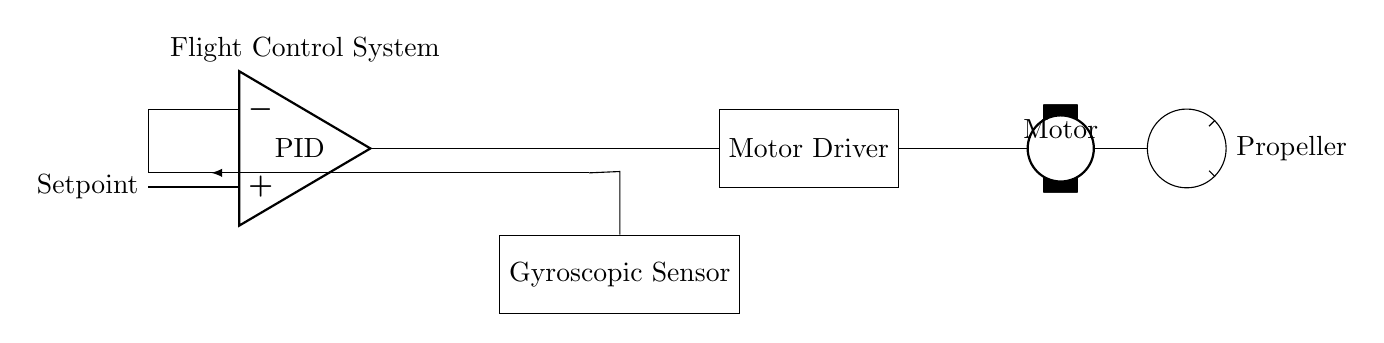What is the main function of the PID controller? The PID controller's main function is to maintain the desired flight path or attitude by adjusting the control signals to the motor based on the error from the setpoint.
Answer: To control flight What type of sensor is used in this system? The circuit diagram shows a gyroscopic sensor, which is used to detect the orientation and angular velocity of the drone.
Answer: Gyroscopic sensor How many main components are present in the flight control system? There are four main components in the system: PID controller, gyroscopic sensor, motor driver, and motor with propeller.
Answer: Four What signifies the feedback loop in the circuit? The feedback loop is indicated by the connection from the gyroscopic sensor back to the PID controller, allowing for real-time adjustments based on the drone's orientation.
Answer: Feedback connection What does the motor driver do in this circuit? The motor driver receives signals from the PID controller and adjusts the power supplied to the motor, controlling its speed and direction.
Answer: Controls motor Which component processes the setpoint signal? The PID controller processes the setpoint signal to maintain the drone’s stability and desired position during flight.
Answer: PID controller 